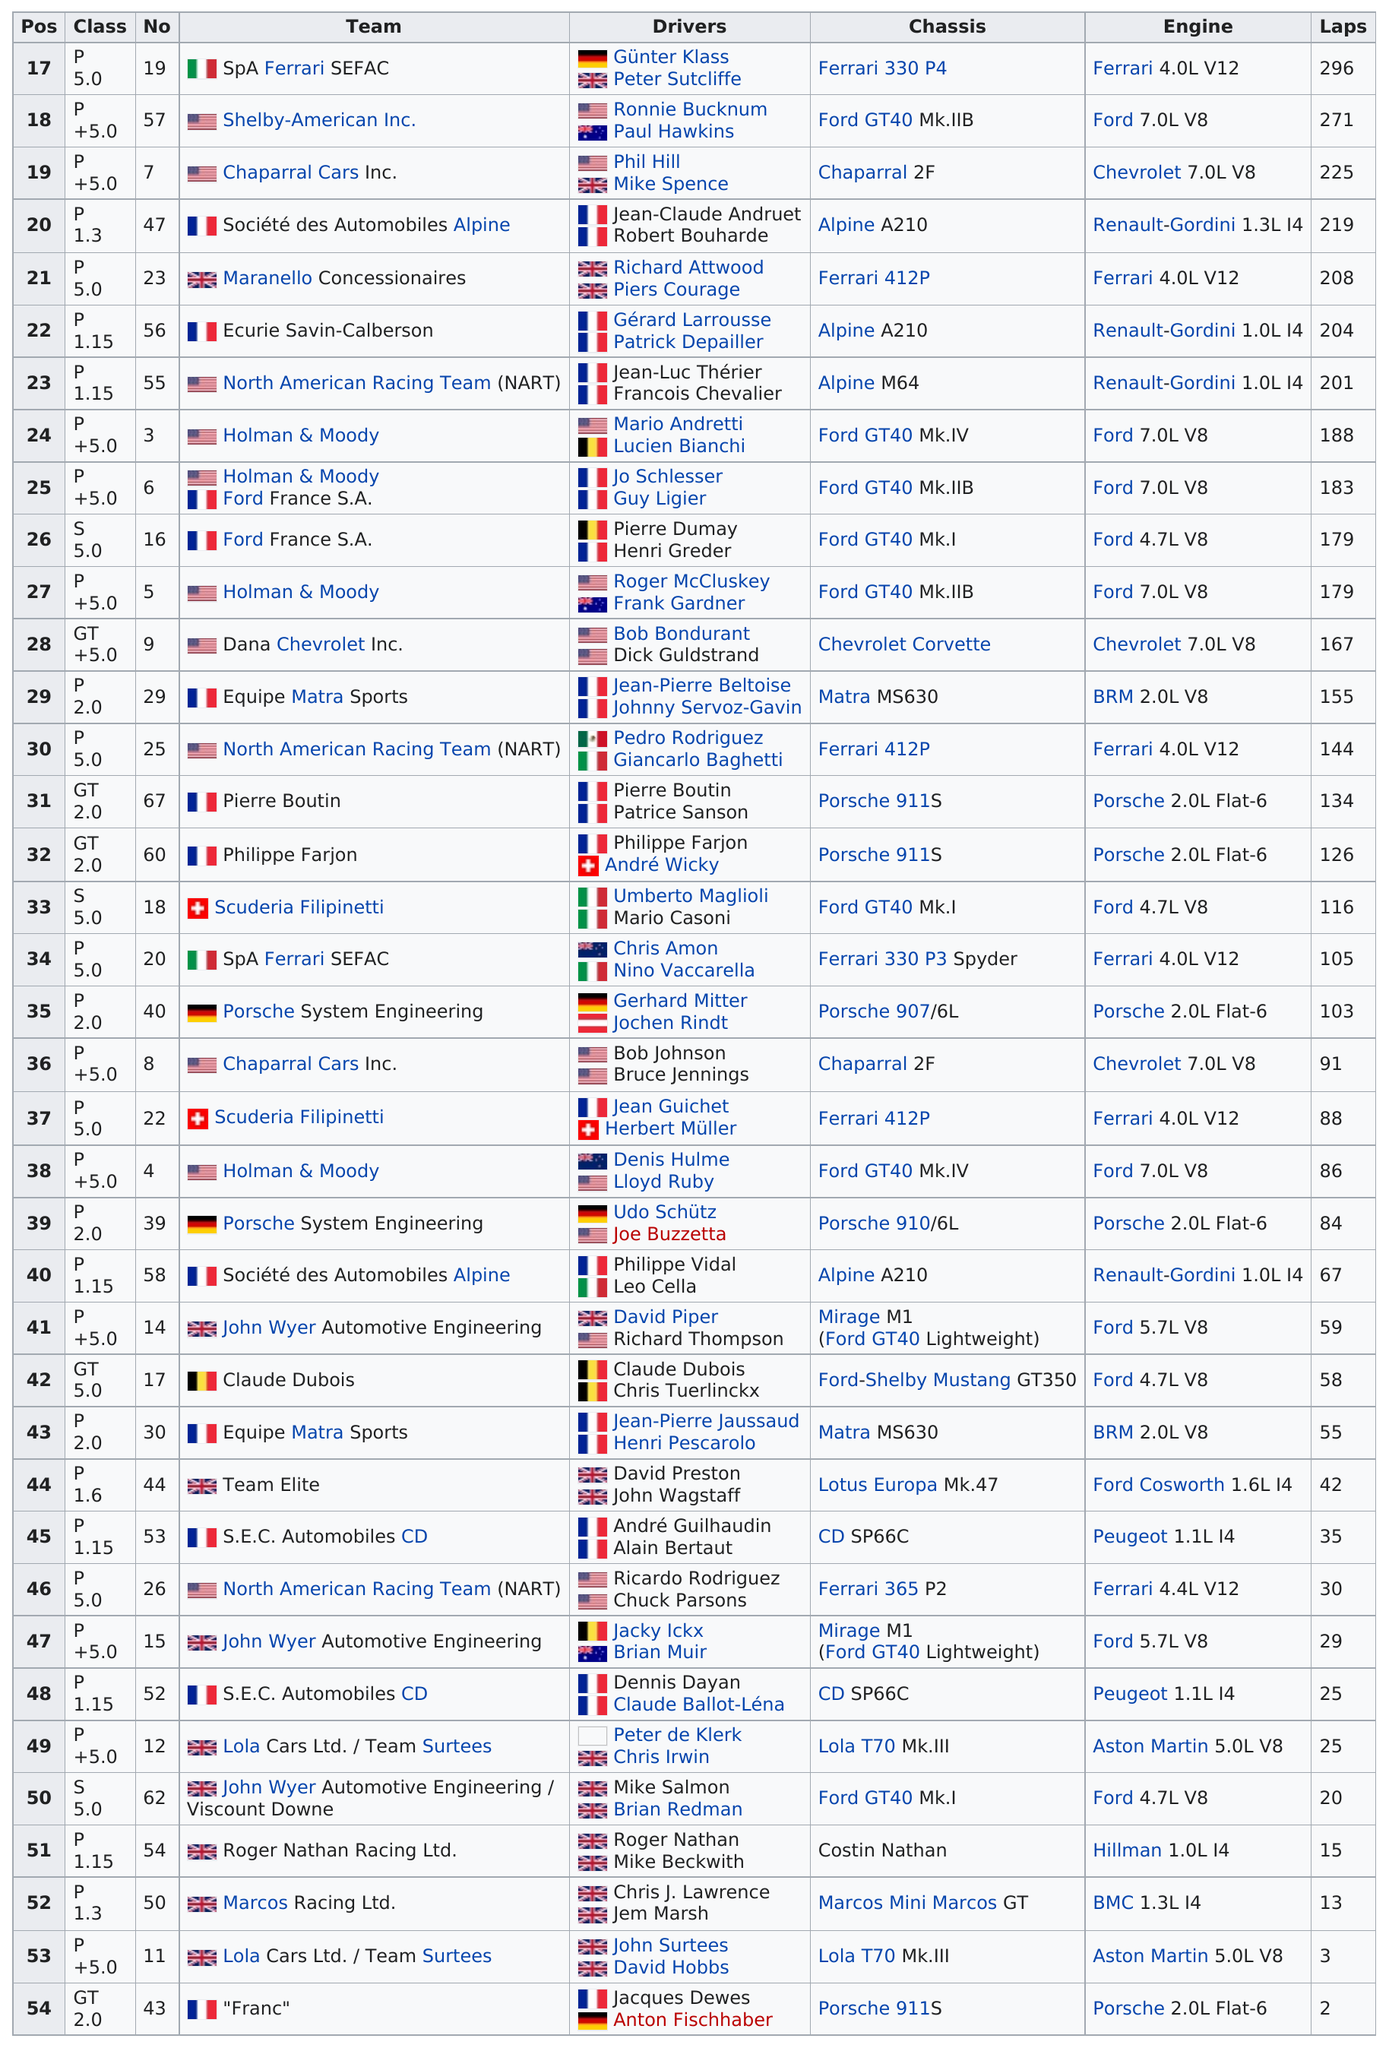Draw attention to some important aspects in this diagram. There is at least one racing team that completed fewer than 160 laps. That team is Equipe Matra Sports. Ronnie Bucknum completed 271 laps. The Franc team completed only two laps in the race. The team that completed the most laps according to the provided chart was SpA Ferrari SEFAC. The team that completed the most laps was SpA Ferrari SEFAC. 